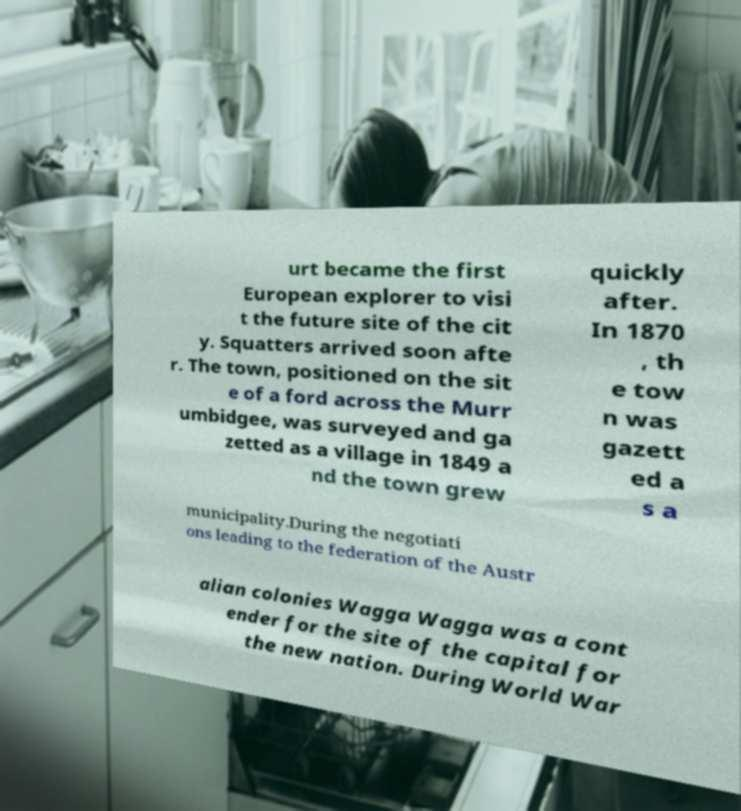I need the written content from this picture converted into text. Can you do that? urt became the first European explorer to visi t the future site of the cit y. Squatters arrived soon afte r. The town, positioned on the sit e of a ford across the Murr umbidgee, was surveyed and ga zetted as a village in 1849 a nd the town grew quickly after. In 1870 , th e tow n was gazett ed a s a municipality.During the negotiati ons leading to the federation of the Austr alian colonies Wagga Wagga was a cont ender for the site of the capital for the new nation. During World War 